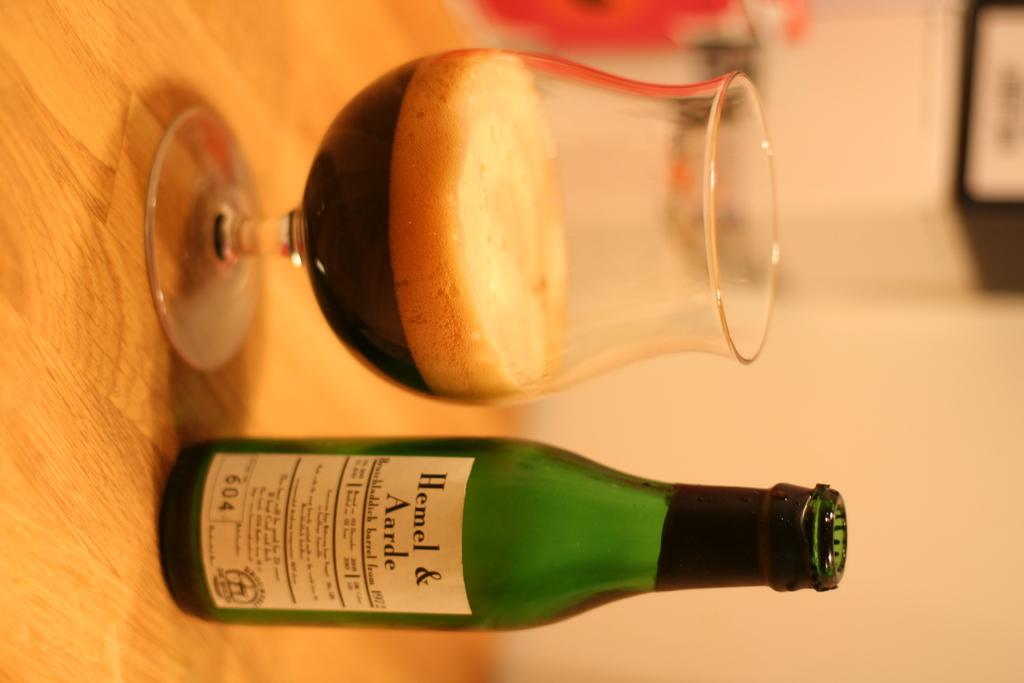<image>
Offer a succinct explanation of the picture presented. A bottle of Hemel & Aarde is on a table next to a glass. 